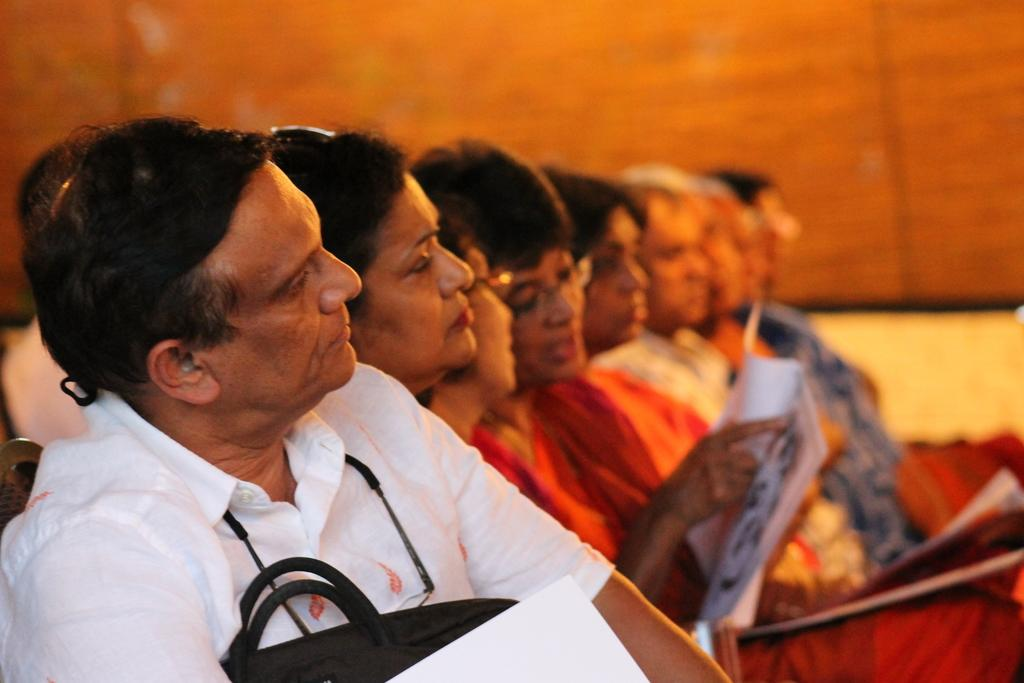What are the people in the image doing? The people in the image are sitting in a row. What are the people wearing? The people are wearing clothes. Can you describe any accessories that some people are wearing? Some people are wearing spectacles. What objects can be seen related to reading or studying? There are papers and a book in the image. How would you describe the background of the image? The background of the image is blurred. What type of thunder can be heard in the image? There is no thunder present in the image, as it is a visual medium and does not contain sound. 